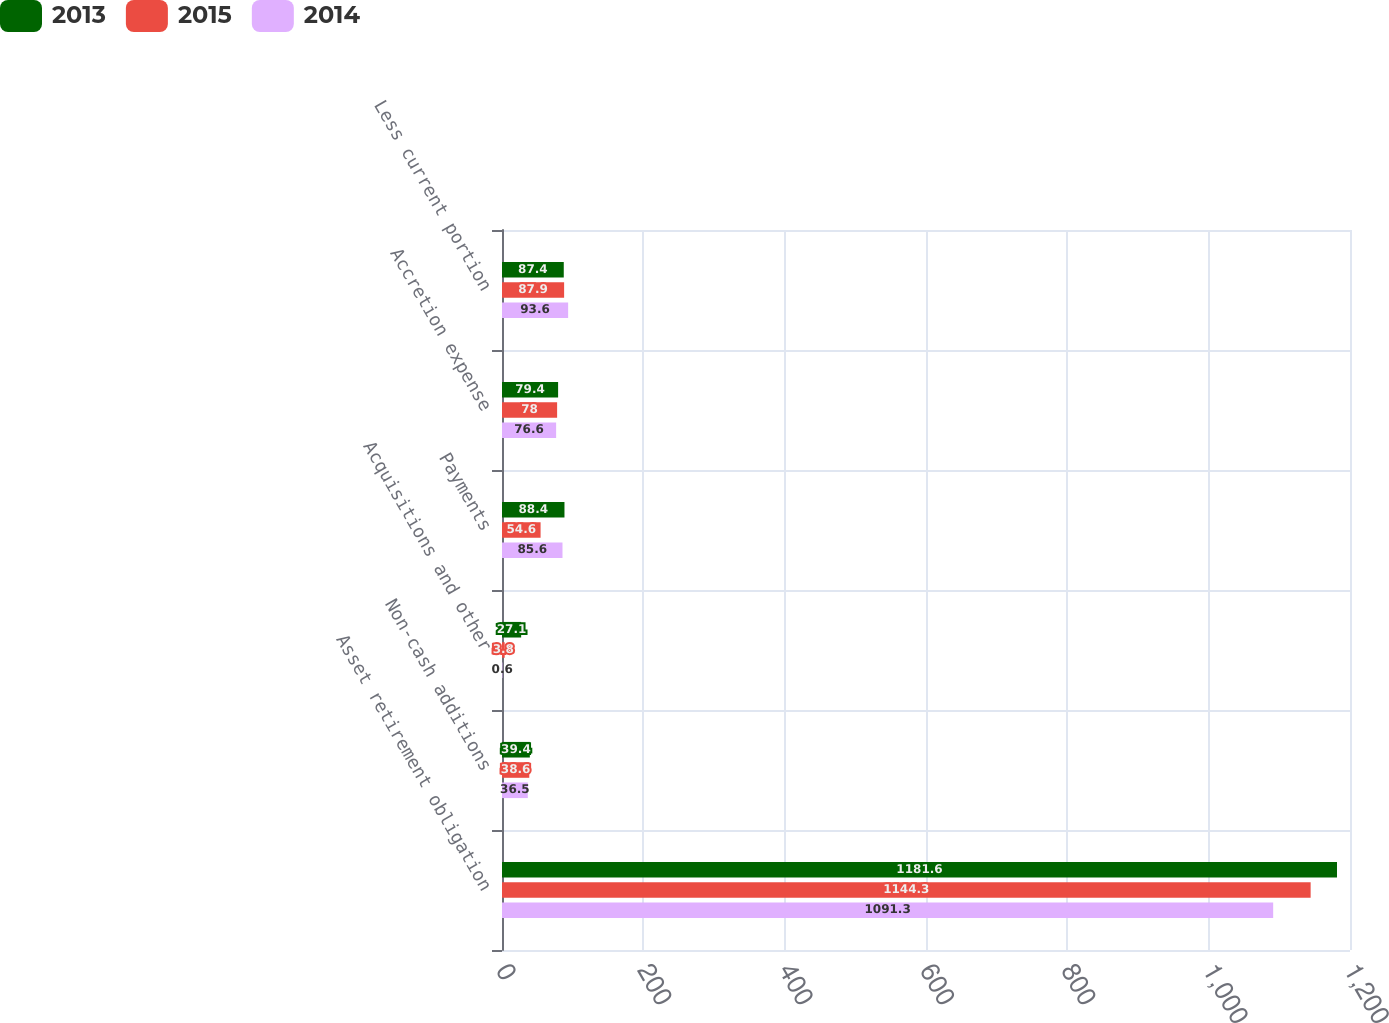<chart> <loc_0><loc_0><loc_500><loc_500><stacked_bar_chart><ecel><fcel>Asset retirement obligation<fcel>Non-cash additions<fcel>Acquisitions and other<fcel>Payments<fcel>Accretion expense<fcel>Less current portion<nl><fcel>2013<fcel>1181.6<fcel>39.4<fcel>27.1<fcel>88.4<fcel>79.4<fcel>87.4<nl><fcel>2015<fcel>1144.3<fcel>38.6<fcel>3.8<fcel>54.6<fcel>78<fcel>87.9<nl><fcel>2014<fcel>1091.3<fcel>36.5<fcel>0.6<fcel>85.6<fcel>76.6<fcel>93.6<nl></chart> 